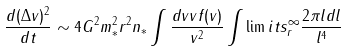<formula> <loc_0><loc_0><loc_500><loc_500>\frac { d ( \Delta v ) ^ { 2 } } { d t } \sim 4 G ^ { 2 } m _ { * } ^ { 2 } r ^ { 2 } n _ { * } \int \frac { d v v f ( v ) } { v ^ { 2 } } \int \lim i t s _ { r } ^ { \infty } \frac { 2 \pi l d l } { l ^ { 4 } }</formula> 